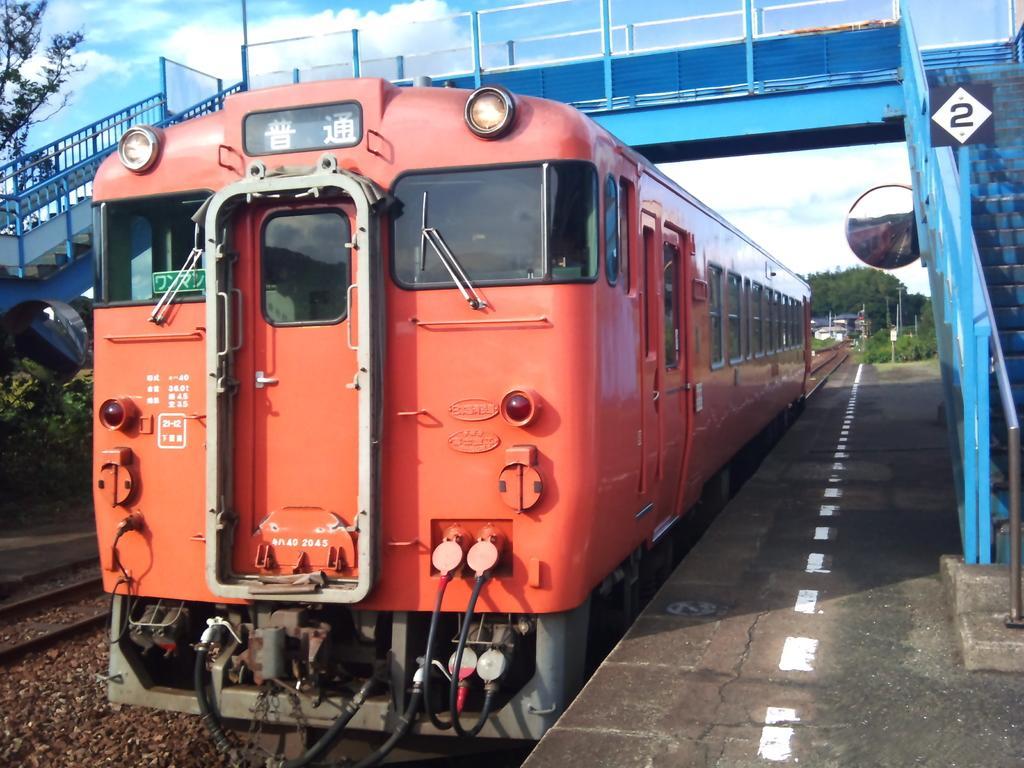Could you give a brief overview of what you see in this image? In this picture we can see a locomotive. On the right side of the locomotive, there is a platform. Behind the locomotive, there are trees, houses and the sky. At the top of the image, there is a passenger walkway with stairs. On the left side of the image, there is a railway track. 